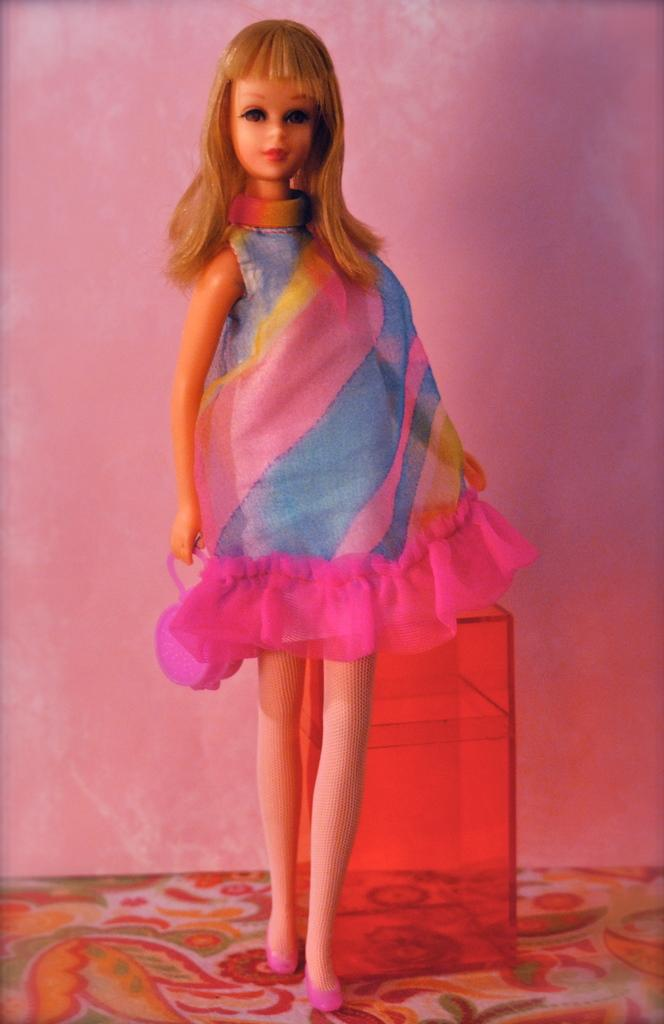What is the main subject of the image? There is a Barbie doll in the image. What is the Barbie doll wearing? The Barbie doll is wearing a colorful dress. Does the Barbie doll have any accessories? Yes, the Barbie doll has shoes. How is the image presented? The image appears to be contained within a red color box. What can be seen in the background of the image? There is a wall visible in the image. What type of cloth is present in the image? There is a cloth with a design in the image. Can you tell me how many crackers are on the table in the image? There is no table or crackers present in the image; it features a Barbie doll in a red color box. What type of family is depicted in the image? There is no family depicted in the image; it features a Barbie doll. 